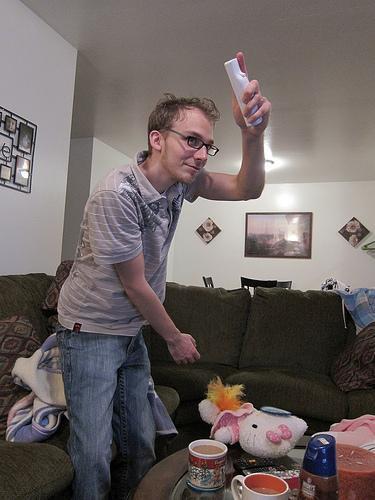How many mugs are on the table?
Give a very brief answer. 2. 